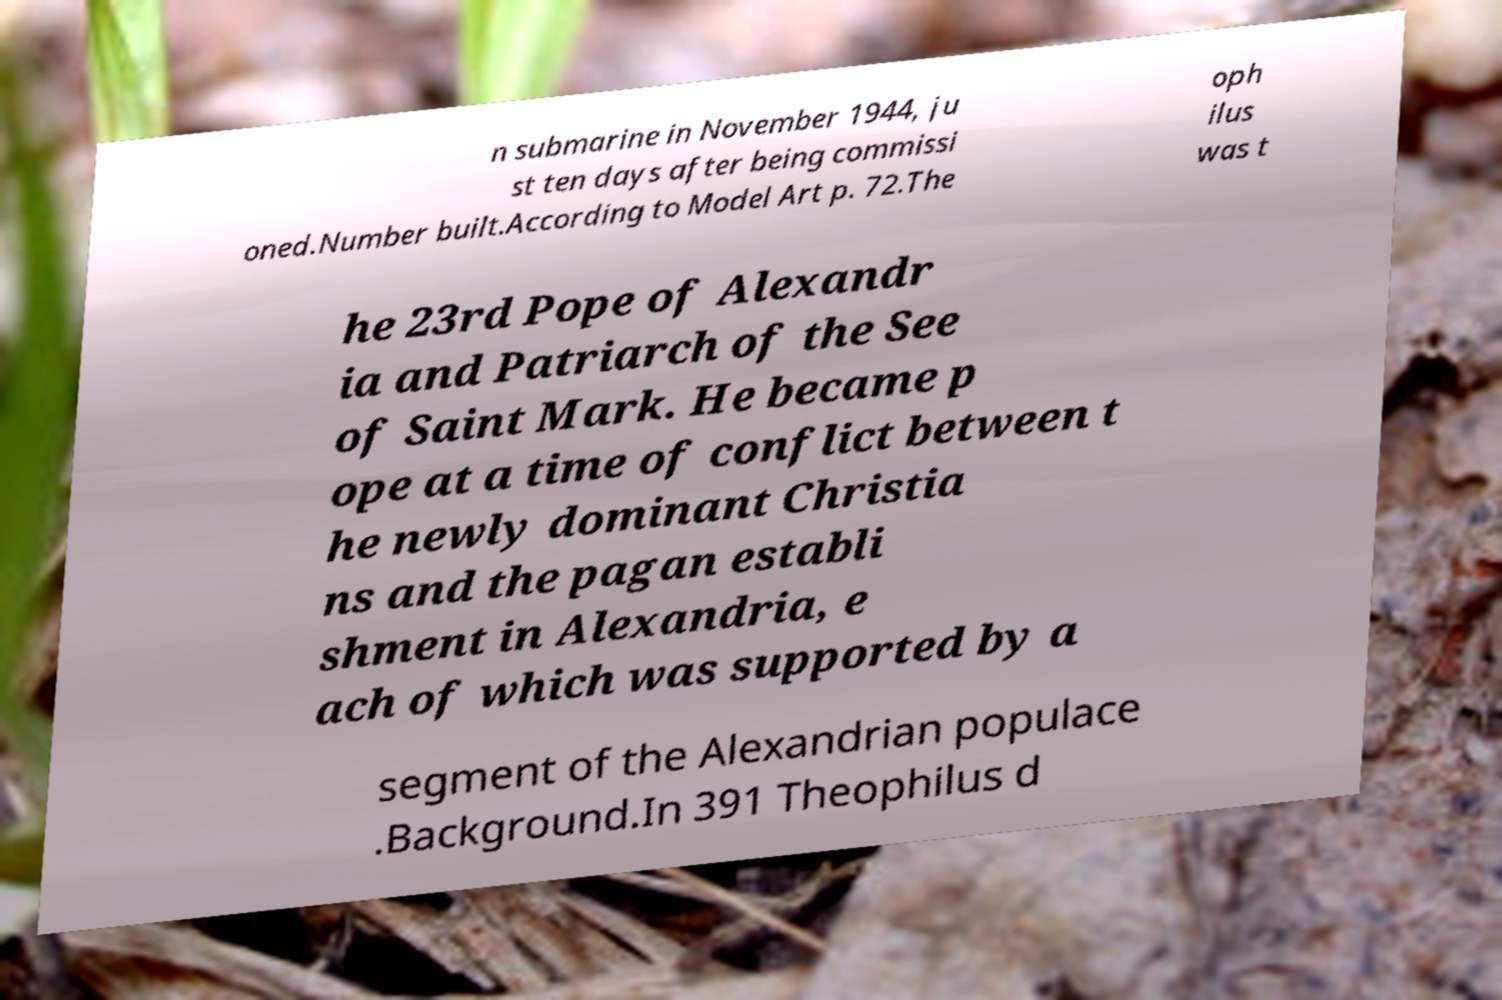What messages or text are displayed in this image? I need them in a readable, typed format. n submarine in November 1944, ju st ten days after being commissi oned.Number built.According to Model Art p. 72.The oph ilus was t he 23rd Pope of Alexandr ia and Patriarch of the See of Saint Mark. He became p ope at a time of conflict between t he newly dominant Christia ns and the pagan establi shment in Alexandria, e ach of which was supported by a segment of the Alexandrian populace .Background.In 391 Theophilus d 